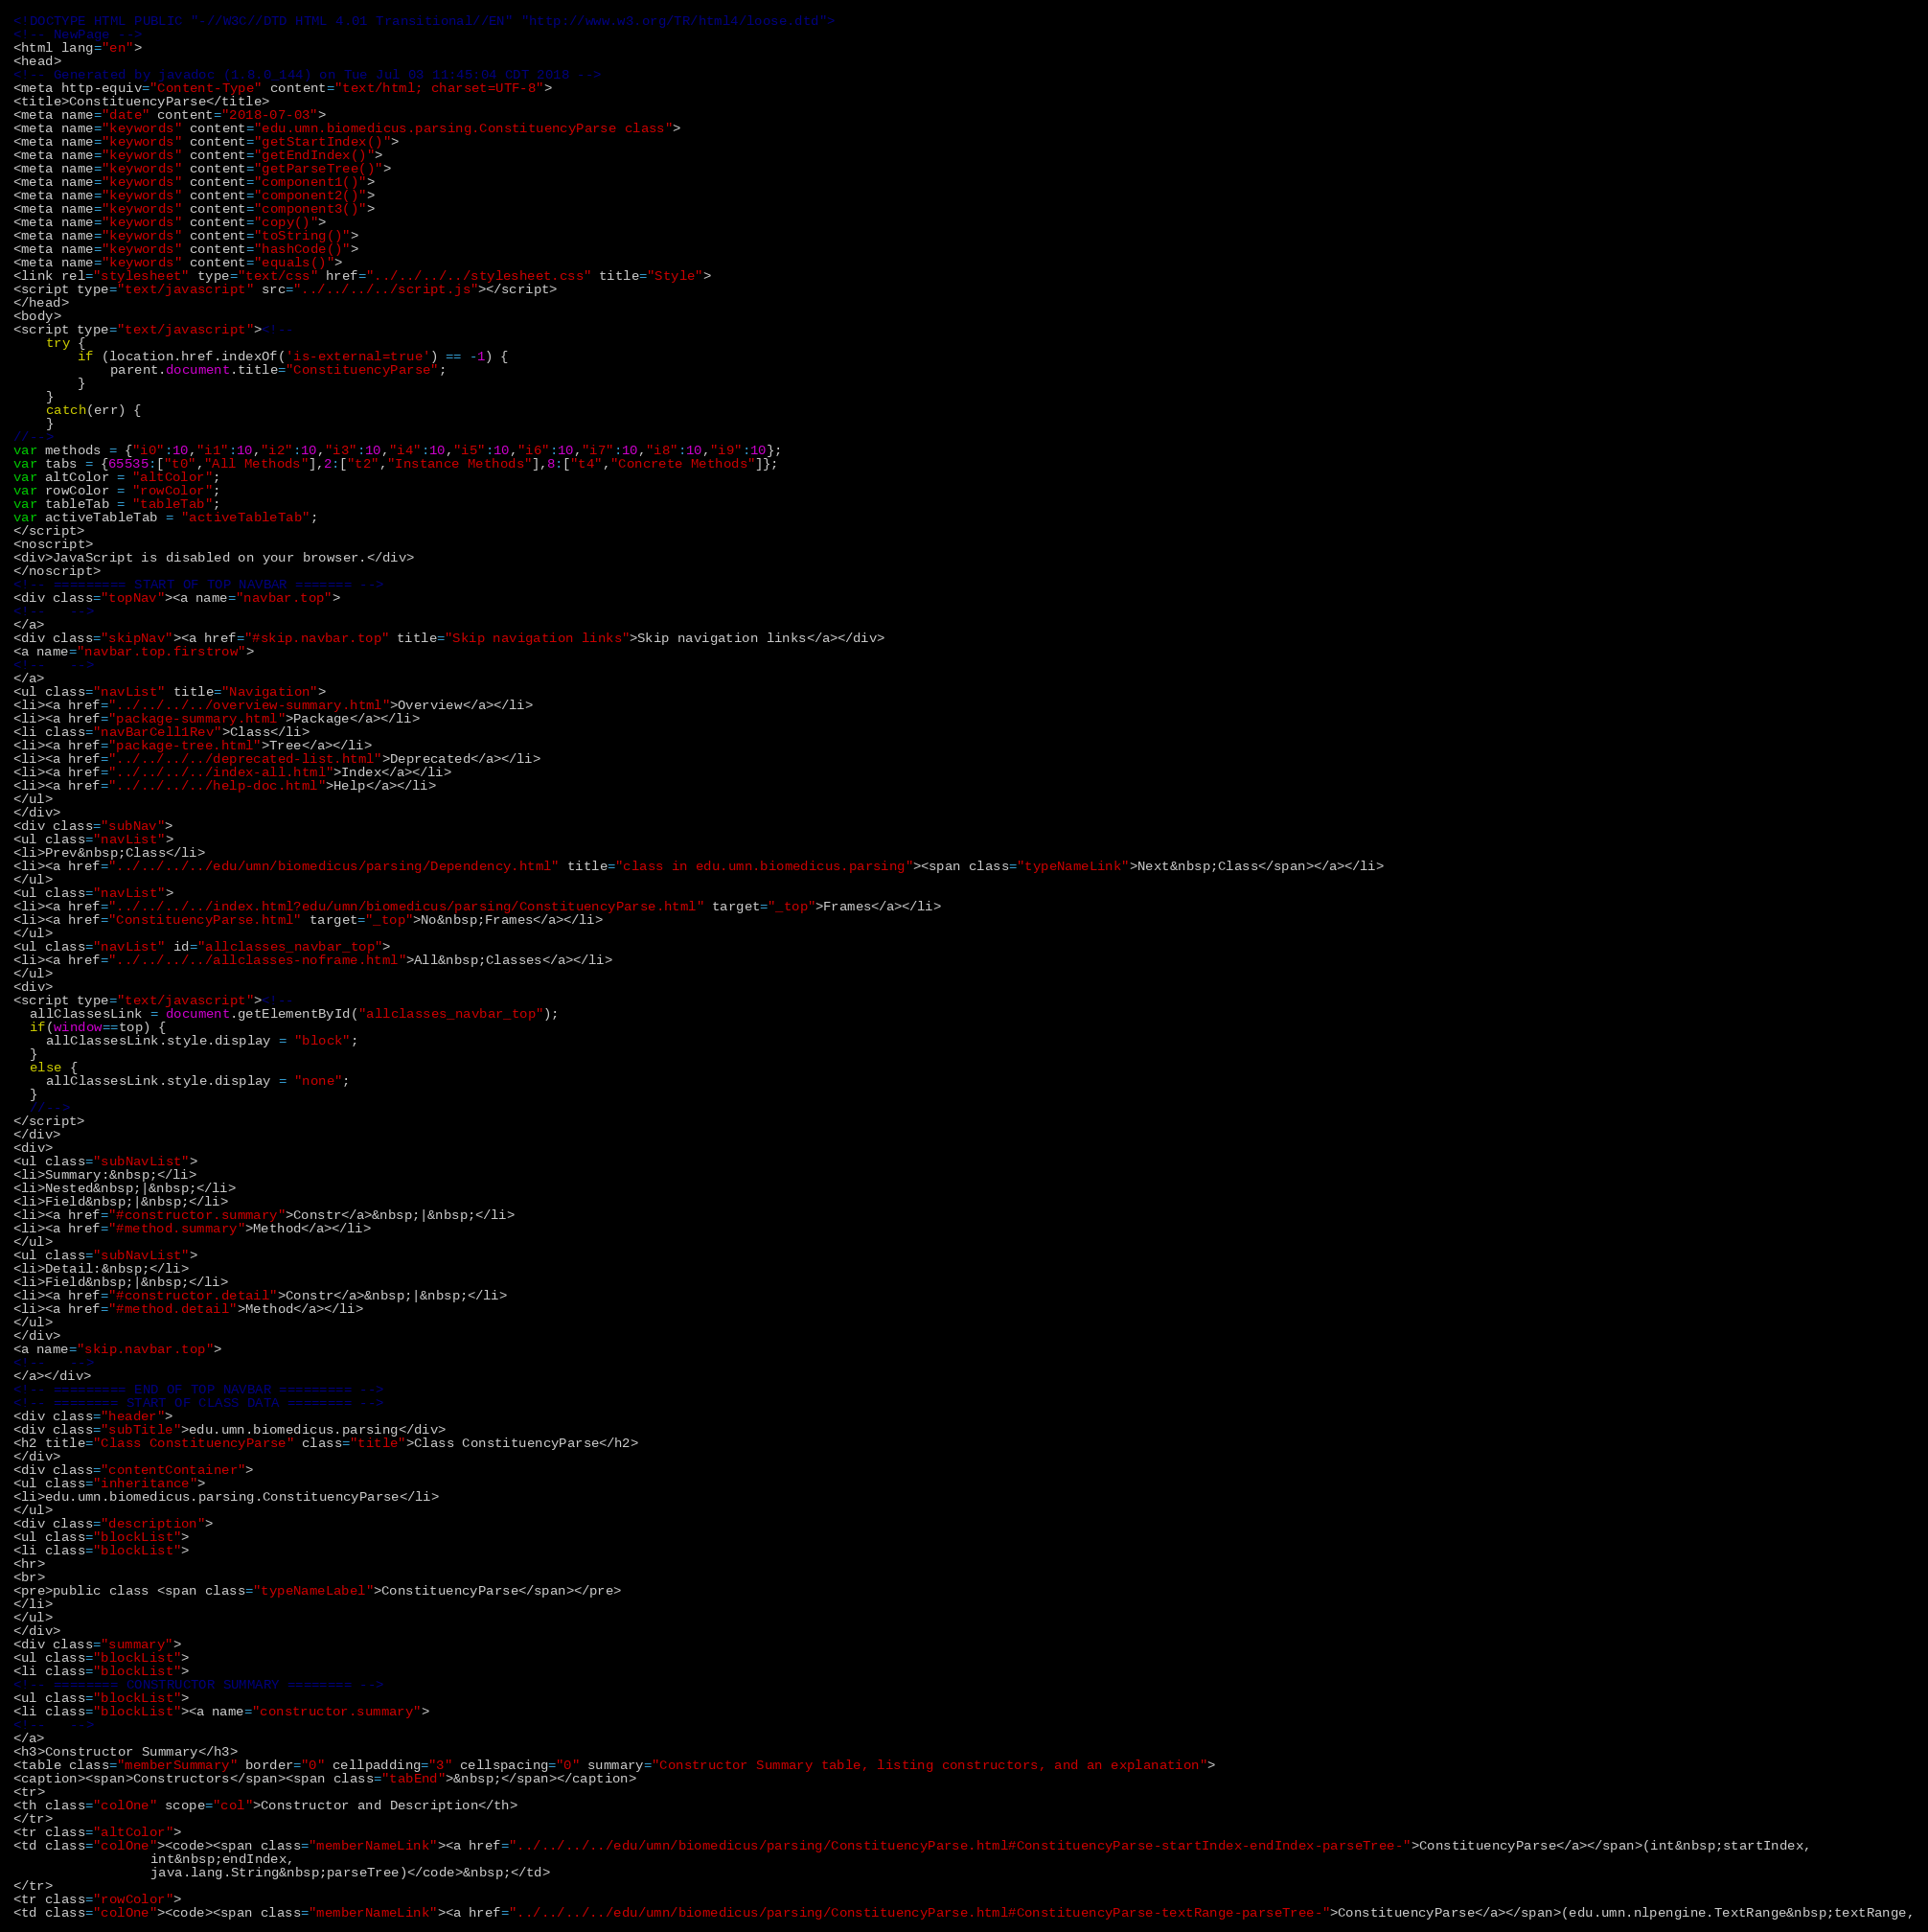Convert code to text. <code><loc_0><loc_0><loc_500><loc_500><_HTML_><!DOCTYPE HTML PUBLIC "-//W3C//DTD HTML 4.01 Transitional//EN" "http://www.w3.org/TR/html4/loose.dtd">
<!-- NewPage -->
<html lang="en">
<head>
<!-- Generated by javadoc (1.8.0_144) on Tue Jul 03 11:45:04 CDT 2018 -->
<meta http-equiv="Content-Type" content="text/html; charset=UTF-8">
<title>ConstituencyParse</title>
<meta name="date" content="2018-07-03">
<meta name="keywords" content="edu.umn.biomedicus.parsing.ConstituencyParse class">
<meta name="keywords" content="getStartIndex()">
<meta name="keywords" content="getEndIndex()">
<meta name="keywords" content="getParseTree()">
<meta name="keywords" content="component1()">
<meta name="keywords" content="component2()">
<meta name="keywords" content="component3()">
<meta name="keywords" content="copy()">
<meta name="keywords" content="toString()">
<meta name="keywords" content="hashCode()">
<meta name="keywords" content="equals()">
<link rel="stylesheet" type="text/css" href="../../../../stylesheet.css" title="Style">
<script type="text/javascript" src="../../../../script.js"></script>
</head>
<body>
<script type="text/javascript"><!--
    try {
        if (location.href.indexOf('is-external=true') == -1) {
            parent.document.title="ConstituencyParse";
        }
    }
    catch(err) {
    }
//-->
var methods = {"i0":10,"i1":10,"i2":10,"i3":10,"i4":10,"i5":10,"i6":10,"i7":10,"i8":10,"i9":10};
var tabs = {65535:["t0","All Methods"],2:["t2","Instance Methods"],8:["t4","Concrete Methods"]};
var altColor = "altColor";
var rowColor = "rowColor";
var tableTab = "tableTab";
var activeTableTab = "activeTableTab";
</script>
<noscript>
<div>JavaScript is disabled on your browser.</div>
</noscript>
<!-- ========= START OF TOP NAVBAR ======= -->
<div class="topNav"><a name="navbar.top">
<!--   -->
</a>
<div class="skipNav"><a href="#skip.navbar.top" title="Skip navigation links">Skip navigation links</a></div>
<a name="navbar.top.firstrow">
<!--   -->
</a>
<ul class="navList" title="Navigation">
<li><a href="../../../../overview-summary.html">Overview</a></li>
<li><a href="package-summary.html">Package</a></li>
<li class="navBarCell1Rev">Class</li>
<li><a href="package-tree.html">Tree</a></li>
<li><a href="../../../../deprecated-list.html">Deprecated</a></li>
<li><a href="../../../../index-all.html">Index</a></li>
<li><a href="../../../../help-doc.html">Help</a></li>
</ul>
</div>
<div class="subNav">
<ul class="navList">
<li>Prev&nbsp;Class</li>
<li><a href="../../../../edu/umn/biomedicus/parsing/Dependency.html" title="class in edu.umn.biomedicus.parsing"><span class="typeNameLink">Next&nbsp;Class</span></a></li>
</ul>
<ul class="navList">
<li><a href="../../../../index.html?edu/umn/biomedicus/parsing/ConstituencyParse.html" target="_top">Frames</a></li>
<li><a href="ConstituencyParse.html" target="_top">No&nbsp;Frames</a></li>
</ul>
<ul class="navList" id="allclasses_navbar_top">
<li><a href="../../../../allclasses-noframe.html">All&nbsp;Classes</a></li>
</ul>
<div>
<script type="text/javascript"><!--
  allClassesLink = document.getElementById("allclasses_navbar_top");
  if(window==top) {
    allClassesLink.style.display = "block";
  }
  else {
    allClassesLink.style.display = "none";
  }
  //-->
</script>
</div>
<div>
<ul class="subNavList">
<li>Summary:&nbsp;</li>
<li>Nested&nbsp;|&nbsp;</li>
<li>Field&nbsp;|&nbsp;</li>
<li><a href="#constructor.summary">Constr</a>&nbsp;|&nbsp;</li>
<li><a href="#method.summary">Method</a></li>
</ul>
<ul class="subNavList">
<li>Detail:&nbsp;</li>
<li>Field&nbsp;|&nbsp;</li>
<li><a href="#constructor.detail">Constr</a>&nbsp;|&nbsp;</li>
<li><a href="#method.detail">Method</a></li>
</ul>
</div>
<a name="skip.navbar.top">
<!--   -->
</a></div>
<!-- ========= END OF TOP NAVBAR ========= -->
<!-- ======== START OF CLASS DATA ======== -->
<div class="header">
<div class="subTitle">edu.umn.biomedicus.parsing</div>
<h2 title="Class ConstituencyParse" class="title">Class ConstituencyParse</h2>
</div>
<div class="contentContainer">
<ul class="inheritance">
<li>edu.umn.biomedicus.parsing.ConstituencyParse</li>
</ul>
<div class="description">
<ul class="blockList">
<li class="blockList">
<hr>
<br>
<pre>public class <span class="typeNameLabel">ConstituencyParse</span></pre>
</li>
</ul>
</div>
<div class="summary">
<ul class="blockList">
<li class="blockList">
<!-- ======== CONSTRUCTOR SUMMARY ======== -->
<ul class="blockList">
<li class="blockList"><a name="constructor.summary">
<!--   -->
</a>
<h3>Constructor Summary</h3>
<table class="memberSummary" border="0" cellpadding="3" cellspacing="0" summary="Constructor Summary table, listing constructors, and an explanation">
<caption><span>Constructors</span><span class="tabEnd">&nbsp;</span></caption>
<tr>
<th class="colOne" scope="col">Constructor and Description</th>
</tr>
<tr class="altColor">
<td class="colOne"><code><span class="memberNameLink"><a href="../../../../edu/umn/biomedicus/parsing/ConstituencyParse.html#ConstituencyParse-startIndex-endIndex-parseTree-">ConstituencyParse</a></span>(int&nbsp;startIndex,
                 int&nbsp;endIndex,
                 java.lang.String&nbsp;parseTree)</code>&nbsp;</td>
</tr>
<tr class="rowColor">
<td class="colOne"><code><span class="memberNameLink"><a href="../../../../edu/umn/biomedicus/parsing/ConstituencyParse.html#ConstituencyParse-textRange-parseTree-">ConstituencyParse</a></span>(edu.umn.nlpengine.TextRange&nbsp;textRange,</code> 